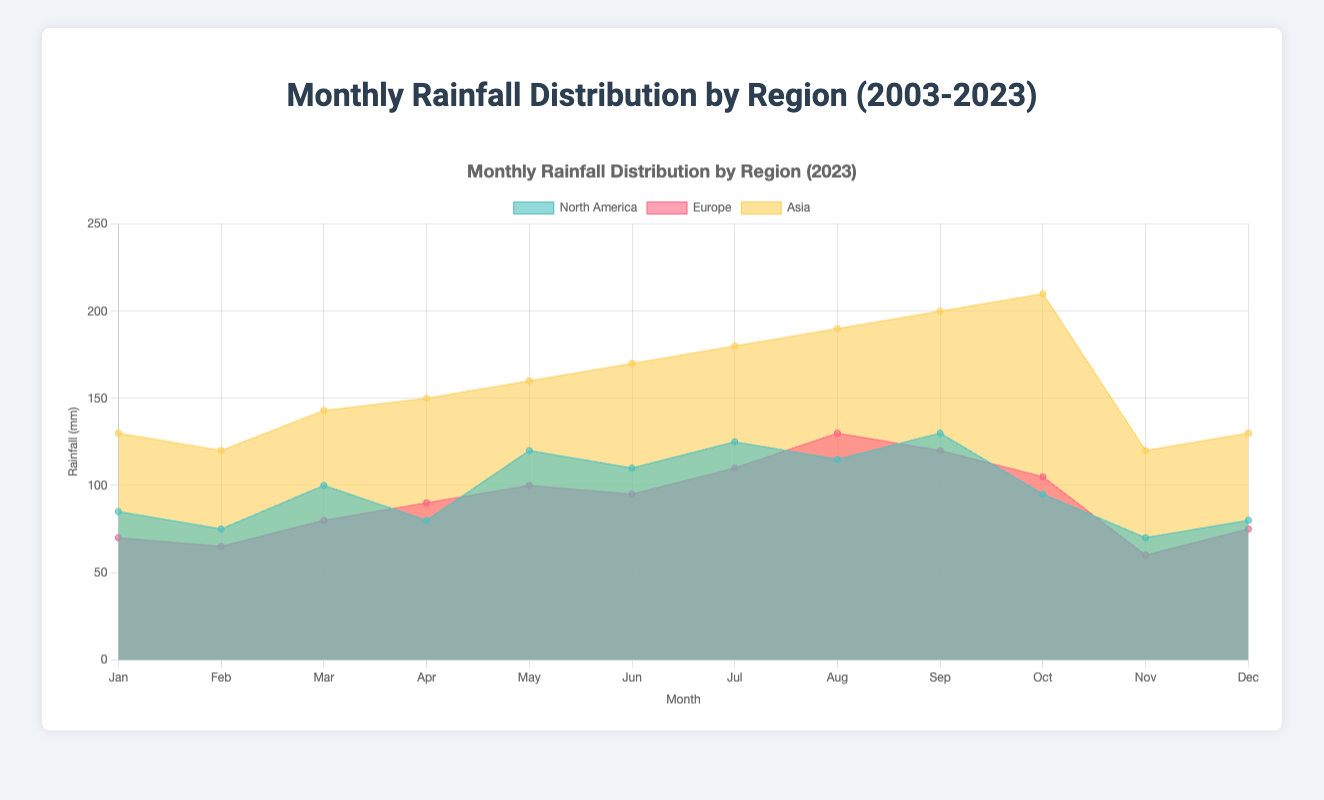What is the title of the chart? The title of the chart is displayed prominently at the top center of the figure. Reading the title directly from the chart gives "Monthly Rainfall Distribution by Region (2023)".
Answer: Monthly Rainfall Distribution by Region (2023) What are the units used on the Y-axis? The units on the Y-axis are typically marked along the axis itself or in the axis title. In this chart, the axis title indicates "Rainfall (mm)", meaning the units are millimeters.
Answer: millimeters Which region had the highest rainfall in August 2023? To find the region with the highest rainfall in August 2023, look at the data points for August in each color-coded region. The values are compared: North America (115 mm), Europe (130 mm), and Asia (190 mm). Asia has the highest.
Answer: Asia What is the average rainfall in North America in 2023? First, obtain the rainfall data for each month in North America in 2023: 85, 75, 100, 80, 120, 110, 125, 115, 130, 95, 70, 80. Sum these values: 85 + 75 + 100 + 80 + 120 + 110 + 125 + 115 + 130 + 95 + 70 + 80 = 1185. Then, divide by the number of months (12): 1185 / 12 = 98.75 mm.
Answer: 98.75 mm Which region experienced the lowest rainfall in March 2023? Compare the March 2023 values for each region: North America (100 mm), Europe (80 mm), and Asia (143 mm). Europe has the lowest rainfall in March 2023 with 80 mm.
Answer: Europe How did the rainfall trend in Asia compare from January to December 2023? Observe the rainfall values for Asia across the months in 2023: Jan (130 mm), Feb (120 mm), Mar (143 mm), Apr (150 mm), May (160 mm), Jun (170 mm), Jul (180 mm), Aug (190 mm), Sep (200 mm), Oct (210 mm), Nov (120 mm), Dec (130 mm). The trend is generally increasing from January to October, peaking in October, and then decreasing slightly in November and December.
Answer: Increasing, peaking in October, then slightly decreasing What is the total rainfall in Europe for July, August, and September in 2023? Data provided shows Europe’s rainfall for these months: July (110 mm), August (130 mm), September (120 mm). Sum these values: 110 + 130 + 120 = 360 mm.
Answer: 360 mm Which months show the highest and lowest rainfall in North America for 2023? Reviewing the North America data for each month in 2023: (Jan 85, Feb 75, Mar 100, Apr 80, May 120, Jun 110, Jul 125, Aug 115, Sep 130, Oct 95, Nov 70, Dec 80). The highest is in September (130 mm) and the lowest in February (75 mm) and November (70 mm).
Answer: Highest: September; Lowest: November Did Europe experience more rainfall than North America in April 2023? Compare April 2023 values for Europe (90 mm) and North America (80 mm). Europe has higher rainfall than North America in April 2023.
Answer: Yes What is the difference in rainfall between Asia and Europe in October 2023? Compare October rainfall values: Asia (210 mm) and Europe (105 mm). Calculate the difference: 210 - 105 = 105 mm.
Answer: 105 mm 